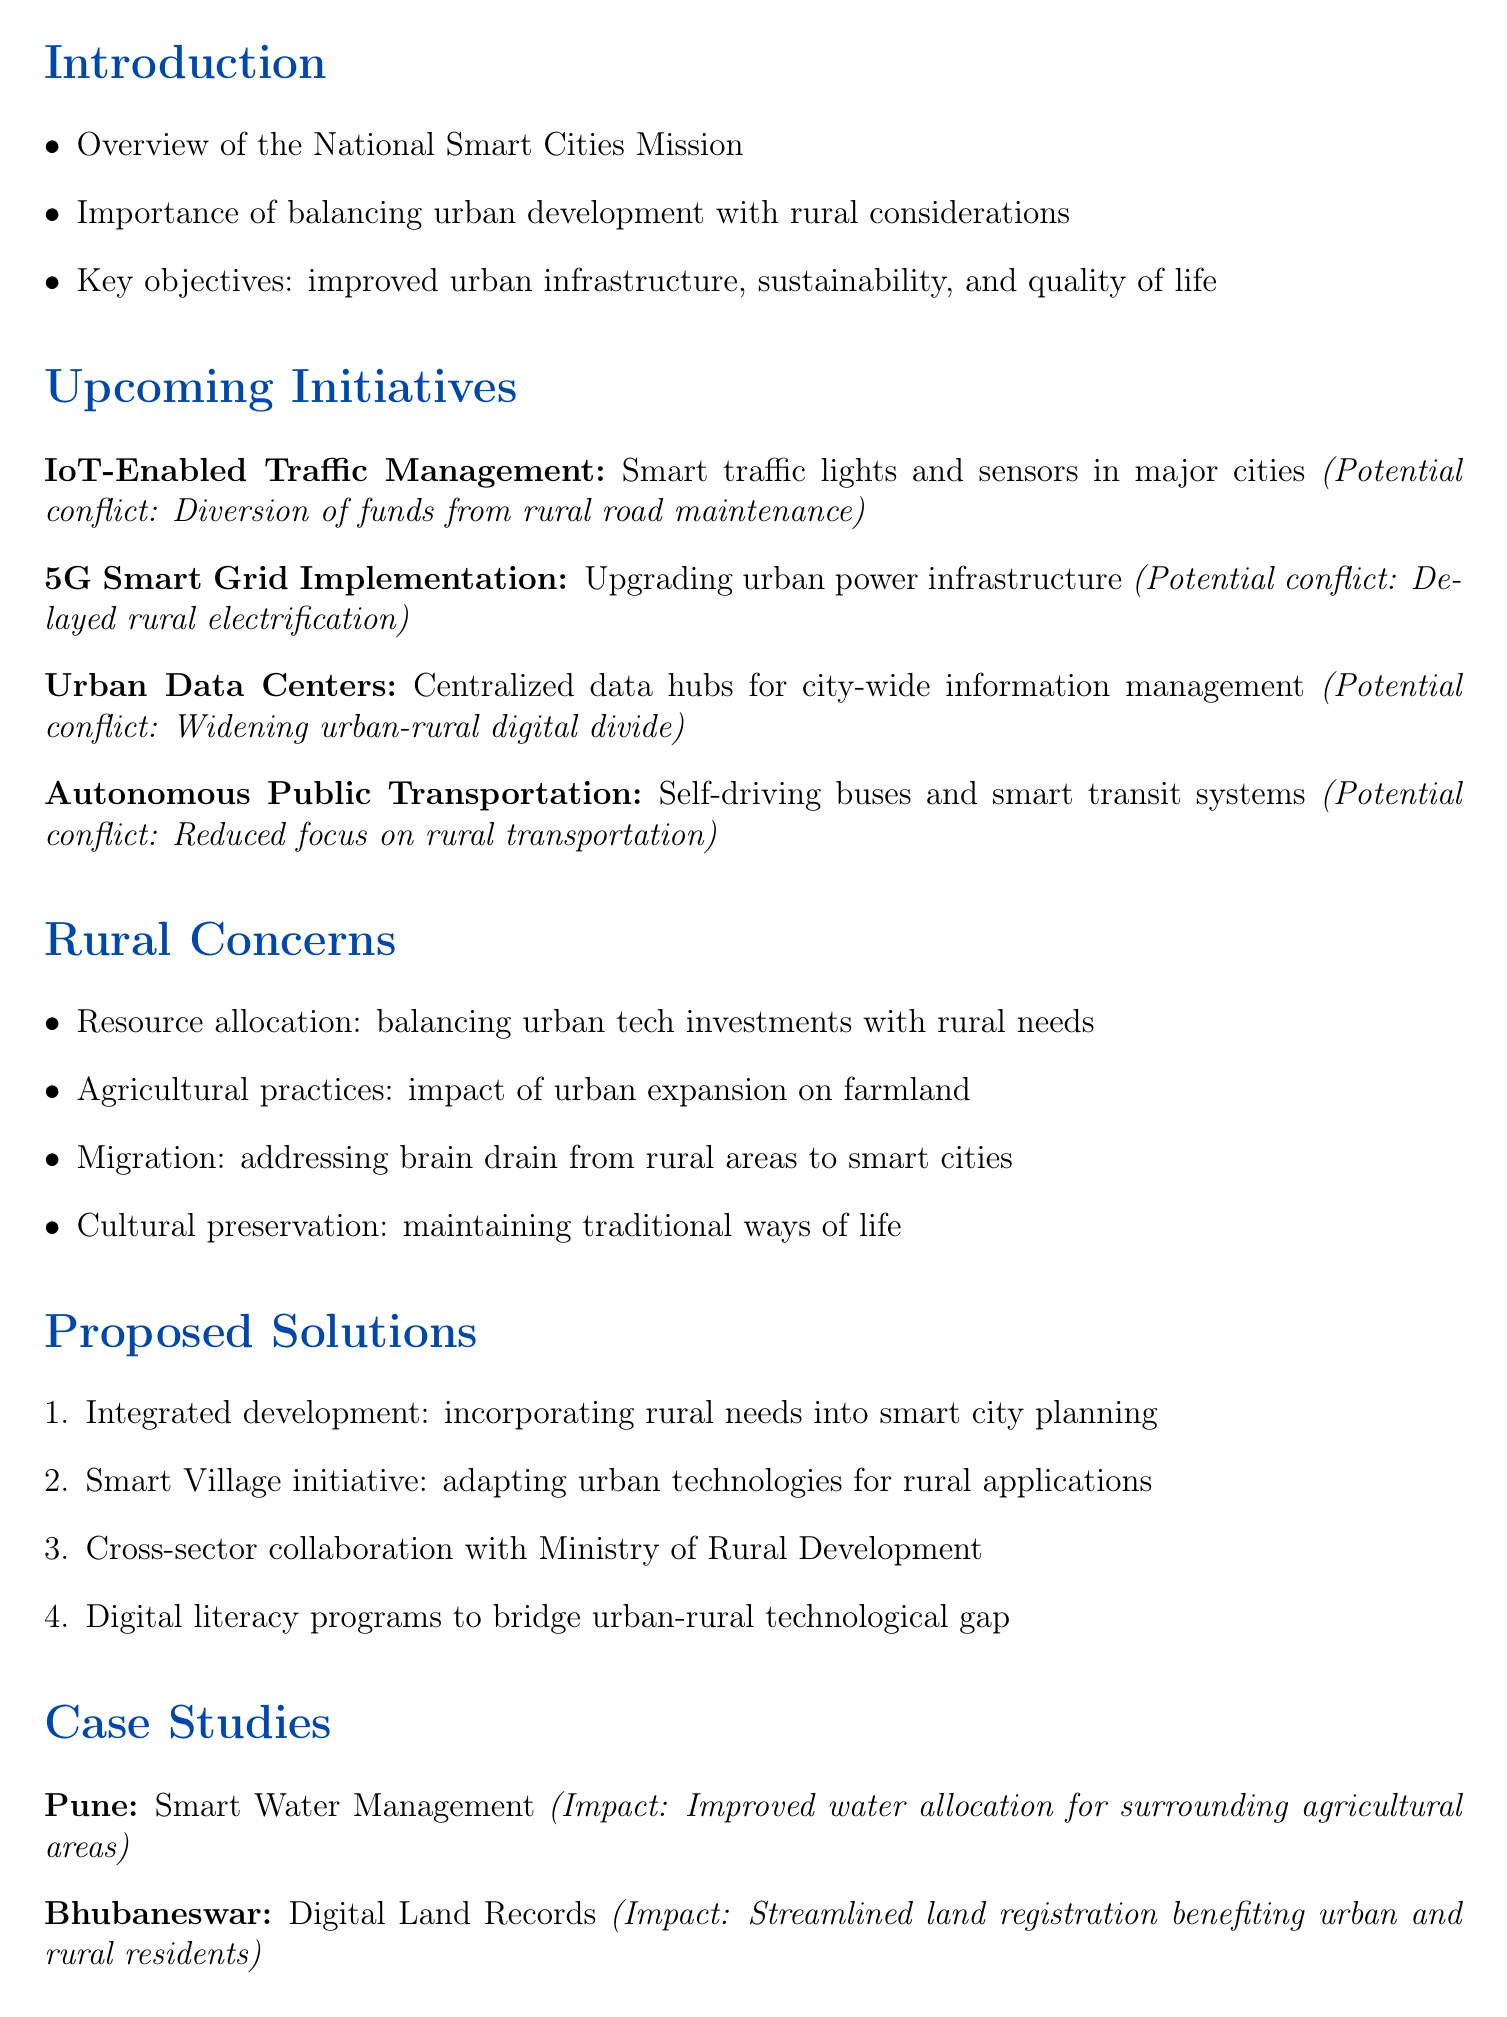What is the title of the memo? The title is presented at the beginning of the memo, which is "Smart City Initiatives and Rural Impact Analysis."
Answer: Smart City Initiatives and Rural Impact Analysis What is one key objective of the National Smart Cities Mission? The key objectives include improved urban infrastructure, sustainability, and quality of life, as mentioned in the introduction.
Answer: Improved urban infrastructure What is a potential conflict of the IoT-Enabled Traffic Management System? The potential conflict is stated alongside the initiative and mentions the diversion of funds.
Answer: Diversion of funds from rural road maintenance projects Which city had an initiative for Smart Water Management? The case studies section provides examples, and Pune is mentioned for this initiative.
Answer: Pune What proposed solution addresses the technological gap? The proposed solutions list includes digital literacy programs for urban and rural populations.
Answer: Digital literacy programs What is a concern regarding agricultural practices mentioned in the memo? The memo identifies the impact of urban expansion on farmland as a rural concern.
Answer: Impact of urban expansion on farmland Which initiative was mentioned to potentially reduce focus on rural transportation? The discussion on upcoming initiatives states that Autonomous Public Transportation might reduce this focus.
Answer: Autonomous Public Transportation What is recommended for fostering dialogue between planners and rural representatives? The conclusion section suggests establishing a Smart City-Rural Liaison Committee for better communication.
Answer: Smart City-Rural Liaison Committee What does the Smart Village initiative entail? In the proposed solutions section, it mentions adapting urban technologies for rural applications as part of this initiative.
Answer: Adapting urban technologies for rural applications 